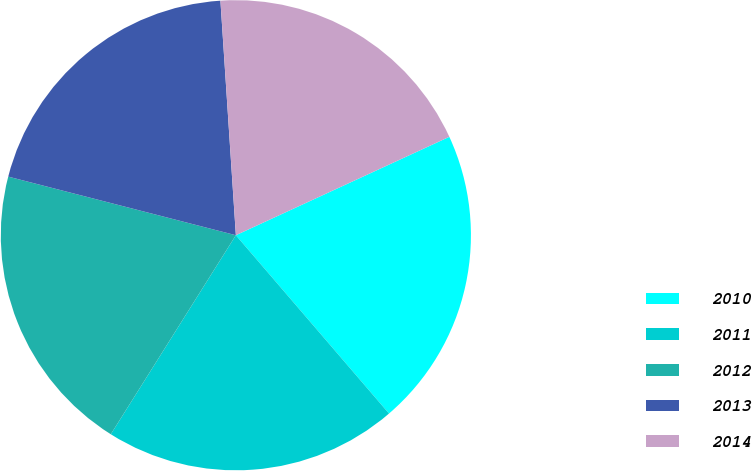Convert chart to OTSL. <chart><loc_0><loc_0><loc_500><loc_500><pie_chart><fcel>2010<fcel>2011<fcel>2012<fcel>2013<fcel>2014<nl><fcel>20.58%<fcel>20.22%<fcel>20.08%<fcel>19.94%<fcel>19.17%<nl></chart> 